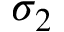<formula> <loc_0><loc_0><loc_500><loc_500>\sigma _ { 2 }</formula> 